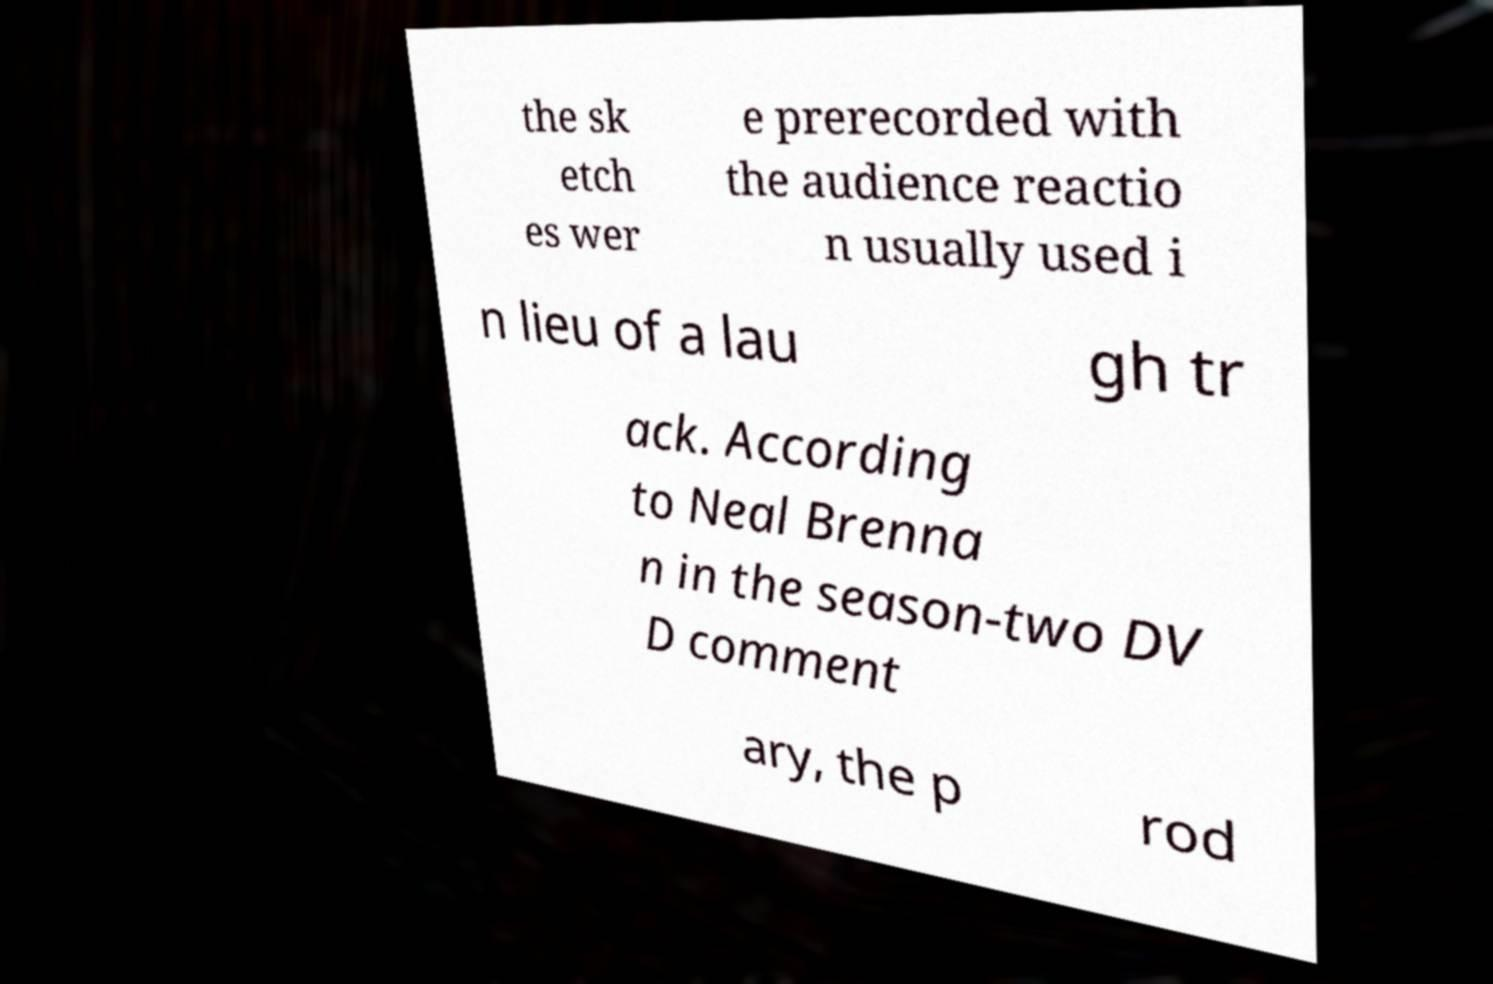Could you assist in decoding the text presented in this image and type it out clearly? the sk etch es wer e prerecorded with the audience reactio n usually used i n lieu of a lau gh tr ack. According to Neal Brenna n in the season-two DV D comment ary, the p rod 